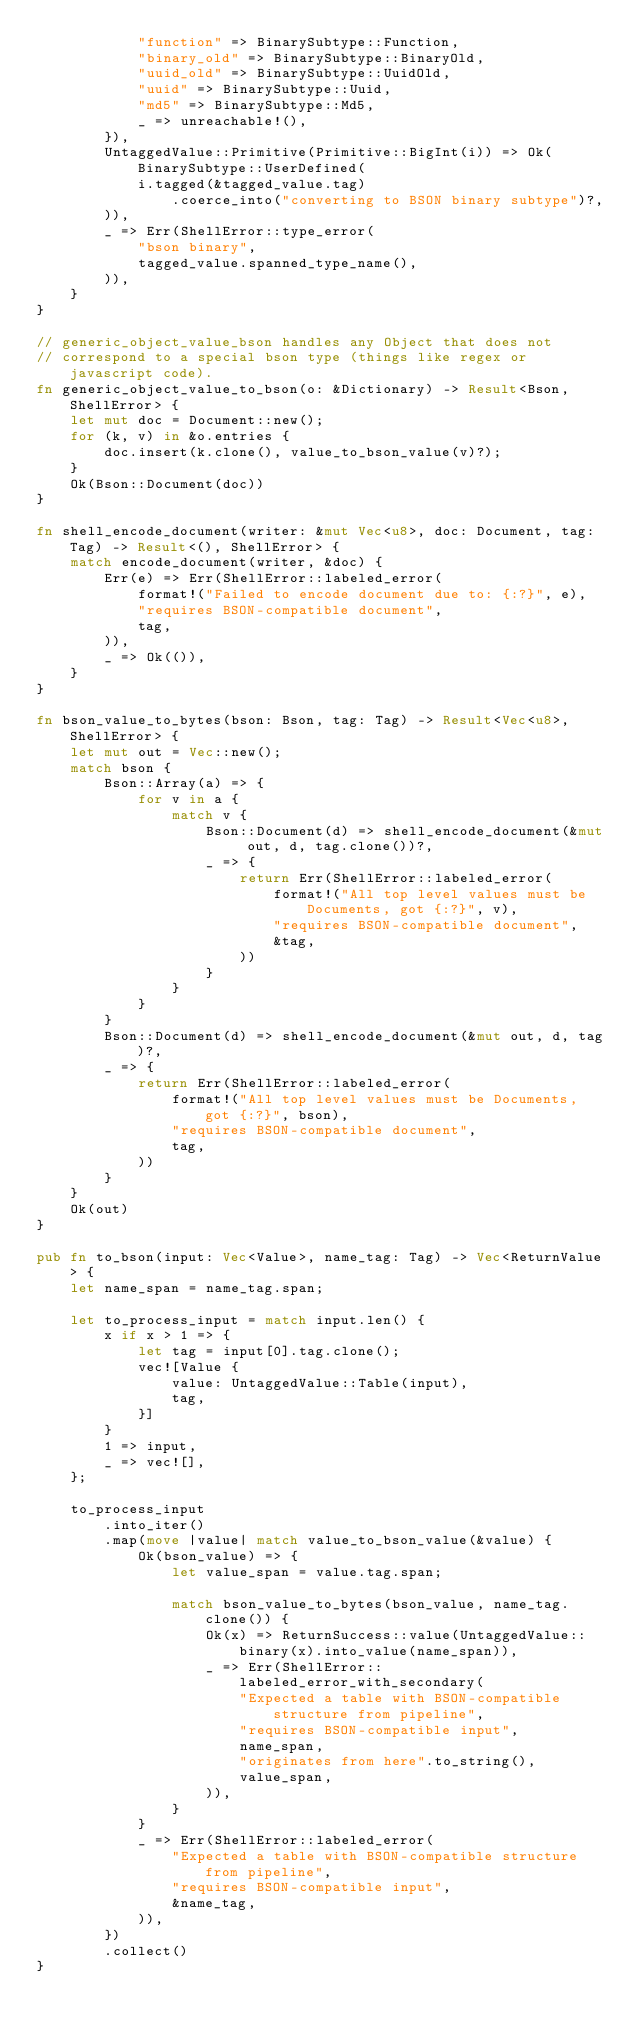<code> <loc_0><loc_0><loc_500><loc_500><_Rust_>            "function" => BinarySubtype::Function,
            "binary_old" => BinarySubtype::BinaryOld,
            "uuid_old" => BinarySubtype::UuidOld,
            "uuid" => BinarySubtype::Uuid,
            "md5" => BinarySubtype::Md5,
            _ => unreachable!(),
        }),
        UntaggedValue::Primitive(Primitive::BigInt(i)) => Ok(BinarySubtype::UserDefined(
            i.tagged(&tagged_value.tag)
                .coerce_into("converting to BSON binary subtype")?,
        )),
        _ => Err(ShellError::type_error(
            "bson binary",
            tagged_value.spanned_type_name(),
        )),
    }
}

// generic_object_value_bson handles any Object that does not
// correspond to a special bson type (things like regex or javascript code).
fn generic_object_value_to_bson(o: &Dictionary) -> Result<Bson, ShellError> {
    let mut doc = Document::new();
    for (k, v) in &o.entries {
        doc.insert(k.clone(), value_to_bson_value(v)?);
    }
    Ok(Bson::Document(doc))
}

fn shell_encode_document(writer: &mut Vec<u8>, doc: Document, tag: Tag) -> Result<(), ShellError> {
    match encode_document(writer, &doc) {
        Err(e) => Err(ShellError::labeled_error(
            format!("Failed to encode document due to: {:?}", e),
            "requires BSON-compatible document",
            tag,
        )),
        _ => Ok(()),
    }
}

fn bson_value_to_bytes(bson: Bson, tag: Tag) -> Result<Vec<u8>, ShellError> {
    let mut out = Vec::new();
    match bson {
        Bson::Array(a) => {
            for v in a {
                match v {
                    Bson::Document(d) => shell_encode_document(&mut out, d, tag.clone())?,
                    _ => {
                        return Err(ShellError::labeled_error(
                            format!("All top level values must be Documents, got {:?}", v),
                            "requires BSON-compatible document",
                            &tag,
                        ))
                    }
                }
            }
        }
        Bson::Document(d) => shell_encode_document(&mut out, d, tag)?,
        _ => {
            return Err(ShellError::labeled_error(
                format!("All top level values must be Documents, got {:?}", bson),
                "requires BSON-compatible document",
                tag,
            ))
        }
    }
    Ok(out)
}

pub fn to_bson(input: Vec<Value>, name_tag: Tag) -> Vec<ReturnValue> {
    let name_span = name_tag.span;

    let to_process_input = match input.len() {
        x if x > 1 => {
            let tag = input[0].tag.clone();
            vec![Value {
                value: UntaggedValue::Table(input),
                tag,
            }]
        }
        1 => input,
        _ => vec![],
    };

    to_process_input
        .into_iter()
        .map(move |value| match value_to_bson_value(&value) {
            Ok(bson_value) => {
                let value_span = value.tag.span;

                match bson_value_to_bytes(bson_value, name_tag.clone()) {
                    Ok(x) => ReturnSuccess::value(UntaggedValue::binary(x).into_value(name_span)),
                    _ => Err(ShellError::labeled_error_with_secondary(
                        "Expected a table with BSON-compatible structure from pipeline",
                        "requires BSON-compatible input",
                        name_span,
                        "originates from here".to_string(),
                        value_span,
                    )),
                }
            }
            _ => Err(ShellError::labeled_error(
                "Expected a table with BSON-compatible structure from pipeline",
                "requires BSON-compatible input",
                &name_tag,
            )),
        })
        .collect()
}
</code> 